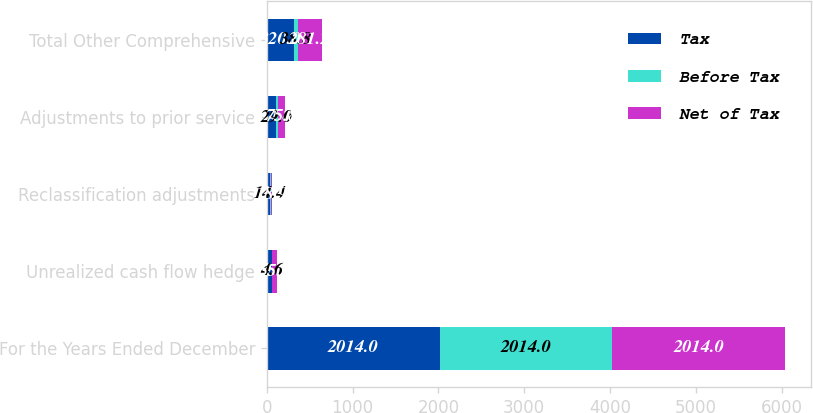<chart> <loc_0><loc_0><loc_500><loc_500><stacked_bar_chart><ecel><fcel>For the Years Ended December<fcel>Unrealized cash flow hedge<fcel>Reclassification adjustments<fcel>Adjustments to prior service<fcel>Total Other Comprehensive<nl><fcel>Tax<fcel>2014<fcel>60.5<fcel>33.3<fcel>104.8<fcel>320<nl><fcel>Before Tax<fcel>2014<fcel>4.6<fcel>14.4<fcel>29<fcel>38.8<nl><fcel>Net of Tax<fcel>2014<fcel>55.9<fcel>18.9<fcel>75.8<fcel>281.2<nl></chart> 